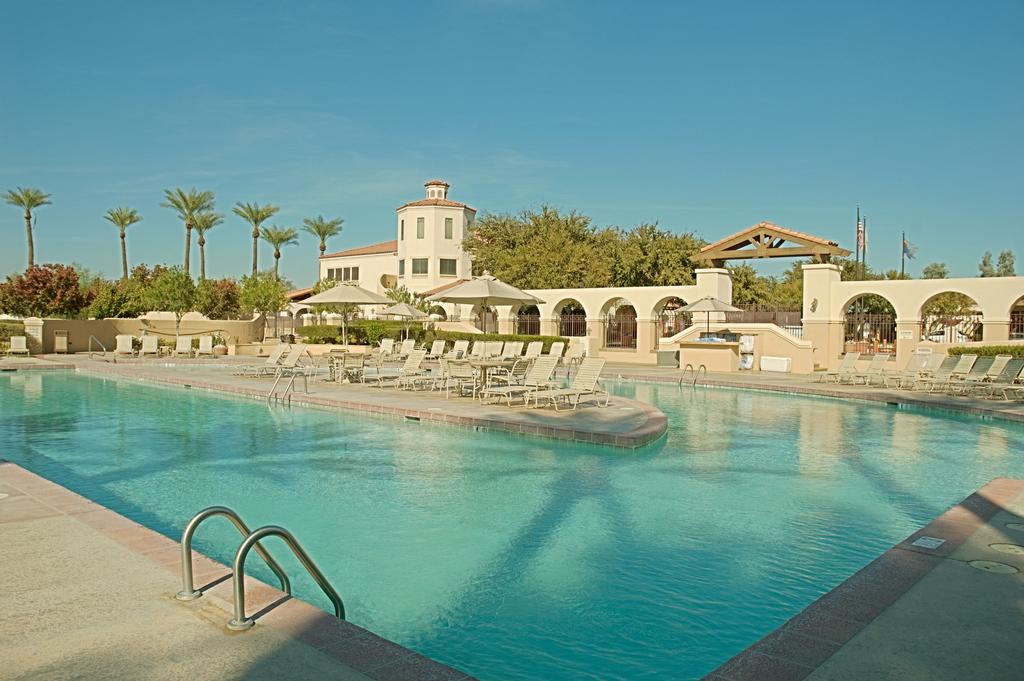What type of location is depicted in the image? The image appears to depict a resort. What is one of the main features of the resort? There is a big swimming pool in the image. What can be seen behind the swimming pool? There is a building behind the swimming pool. What is the surrounding environment like at the resort? The resort is surrounded by plenty of trees. What type of scale can be seen in the image? There is no scale present in the image. Are there any fairies visible in the image? There are no fairies present in the image. 